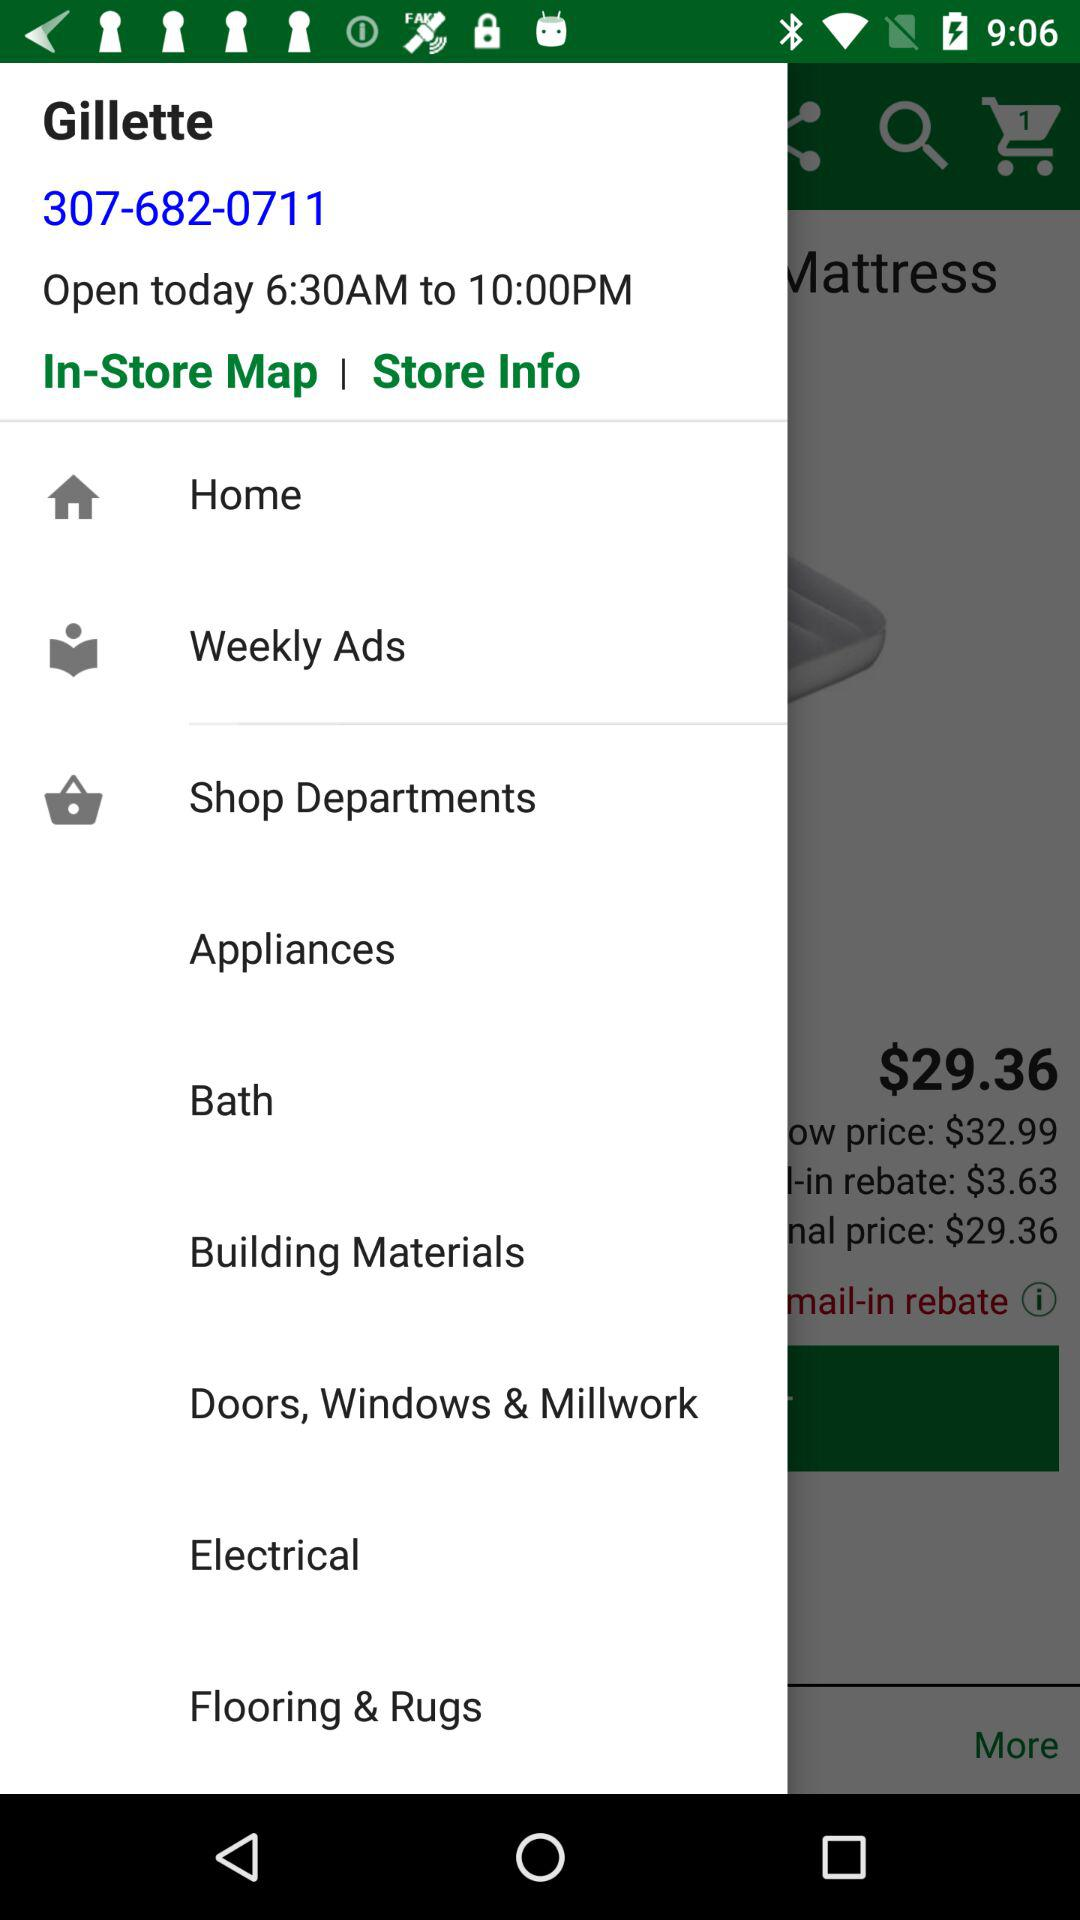What is the opening time of the Gillette store? The opening time of the Gillette store is 6:30 AM. 